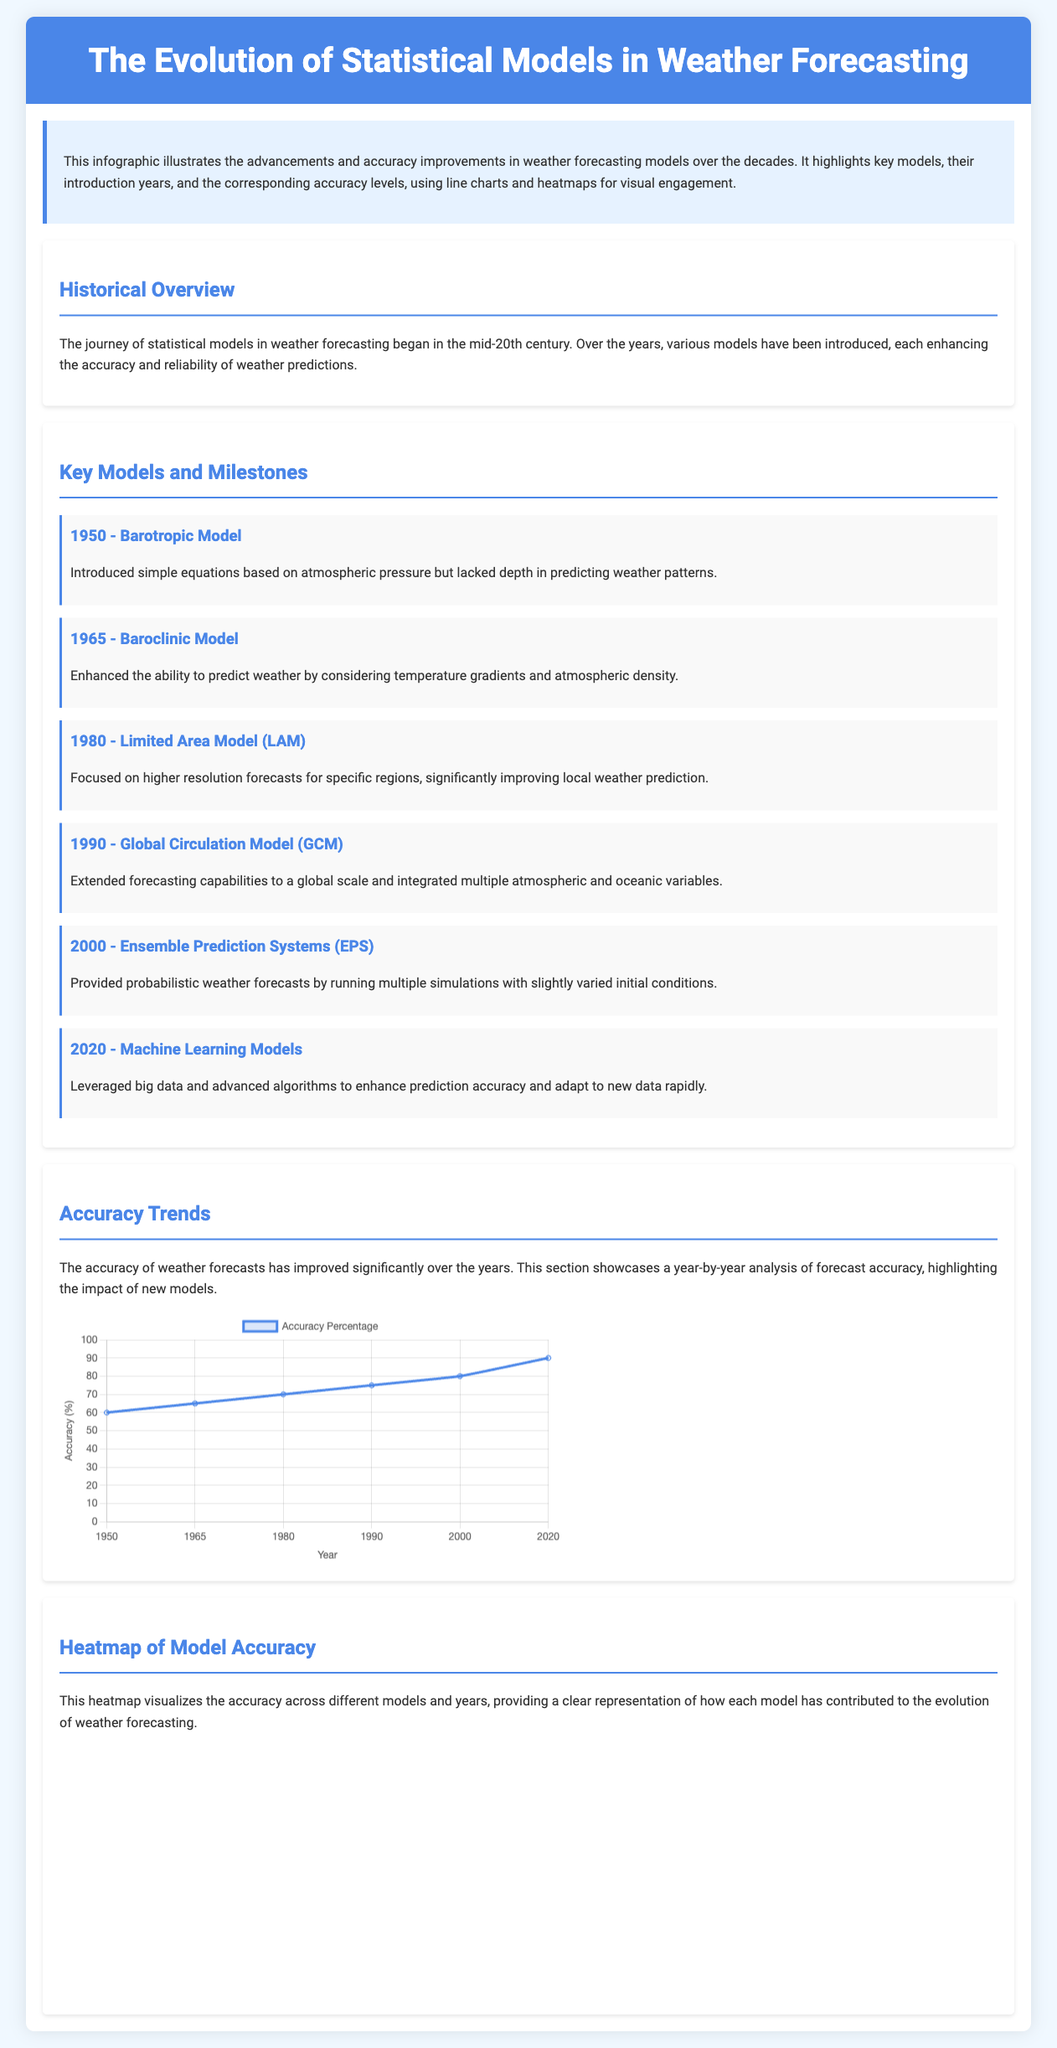What year was the Barotropic Model introduced? The Barotropic Model was introduced in 1950, as mentioned in the key milestones section of the document.
Answer: 1950 What was the accuracy percentage in 2000? The accuracy percentage in the year 2000 was stated to be 80 percent in the accuracy trends chart.
Answer: 80 Which model introduced in 2020 utilizes big data? The Machine Learning Models introduced in 2020 leverage big data and advanced algorithms.
Answer: Machine Learning Models What is the maximum accuracy percentage illustrated in the accuracy trends chart? The maximum accuracy percentage depicted in the chart is 90 percent.
Answer: 90 What advancement did the Baroclinic Model bring in 1965? The Baroclinic Model enhanced the ability to predict weather by considering temperature gradients and atmospheric density.
Answer: Temperature gradients What document type does this infographic represent? This is an infographic with charts that visually presents the evolution of statistical models in weather forecasting.
Answer: Infographic Which model had the highest accuracy in 2020 according to the heatmap? The Machine Learning Models had the highest accuracy, as indicated in the heatmap data.
Answer: Machine Learning Models What key factor do Ensemble Prediction Systems (EPS) provide? Ensemble Prediction Systems provide probabilistic weather forecasts by running multiple simulations.
Answer: Probabilistic forecasts 